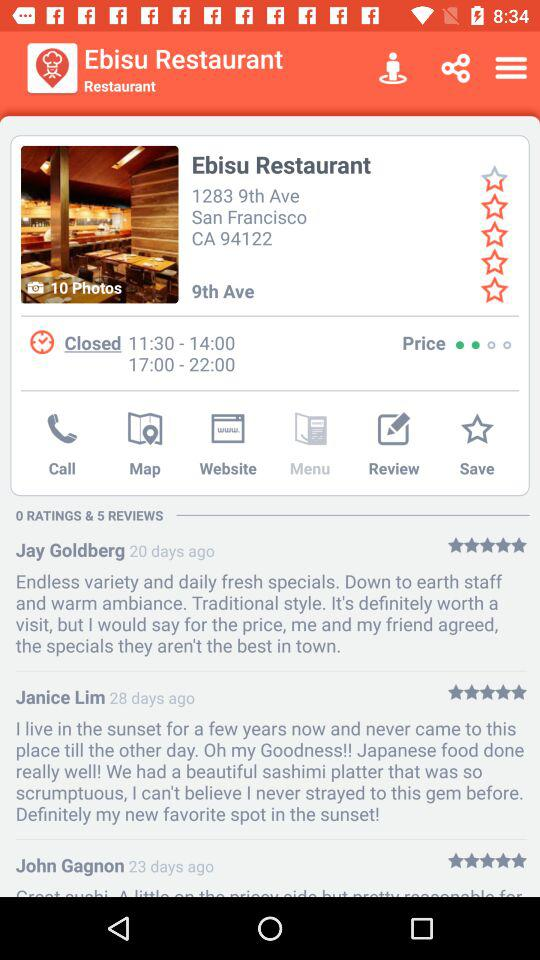What is the location of the "Ebisu Restaurant"? The location of the "Ebisu Restaurant" is 1283 9th Ave., San Francisco, CA 94122. 